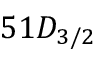<formula> <loc_0><loc_0><loc_500><loc_500>5 1 D _ { 3 / 2 }</formula> 